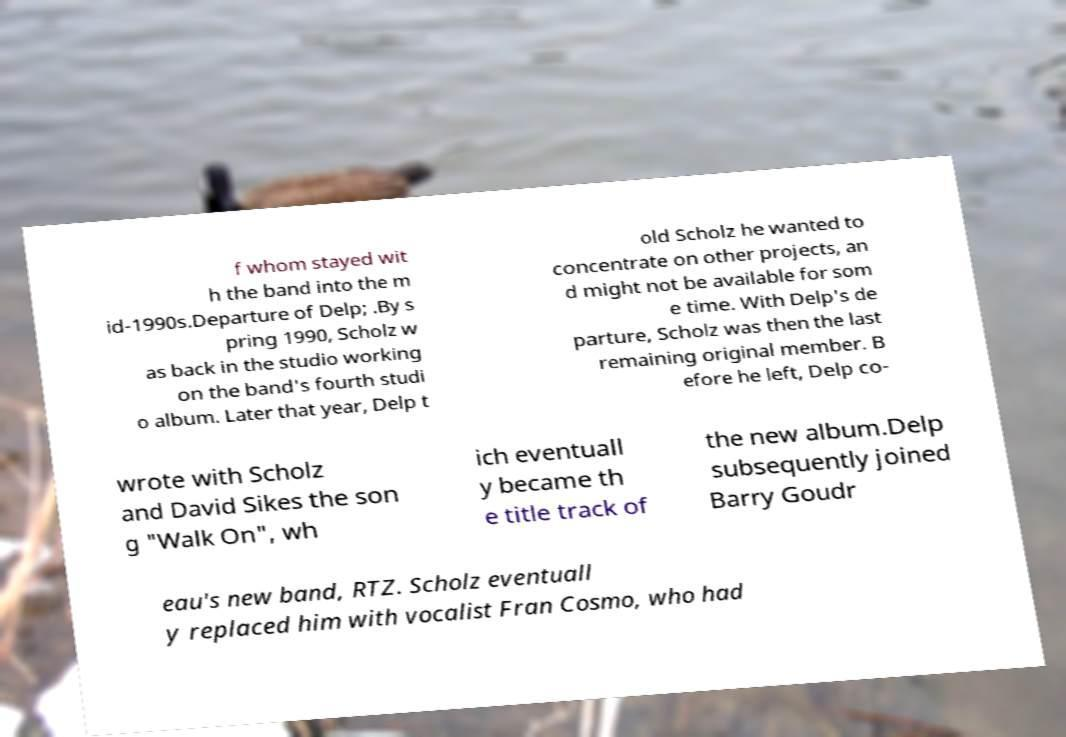What messages or text are displayed in this image? I need them in a readable, typed format. f whom stayed wit h the band into the m id-1990s.Departure of Delp; .By s pring 1990, Scholz w as back in the studio working on the band's fourth studi o album. Later that year, Delp t old Scholz he wanted to concentrate on other projects, an d might not be available for som e time. With Delp's de parture, Scholz was then the last remaining original member. B efore he left, Delp co- wrote with Scholz and David Sikes the son g "Walk On", wh ich eventuall y became th e title track of the new album.Delp subsequently joined Barry Goudr eau's new band, RTZ. Scholz eventuall y replaced him with vocalist Fran Cosmo, who had 